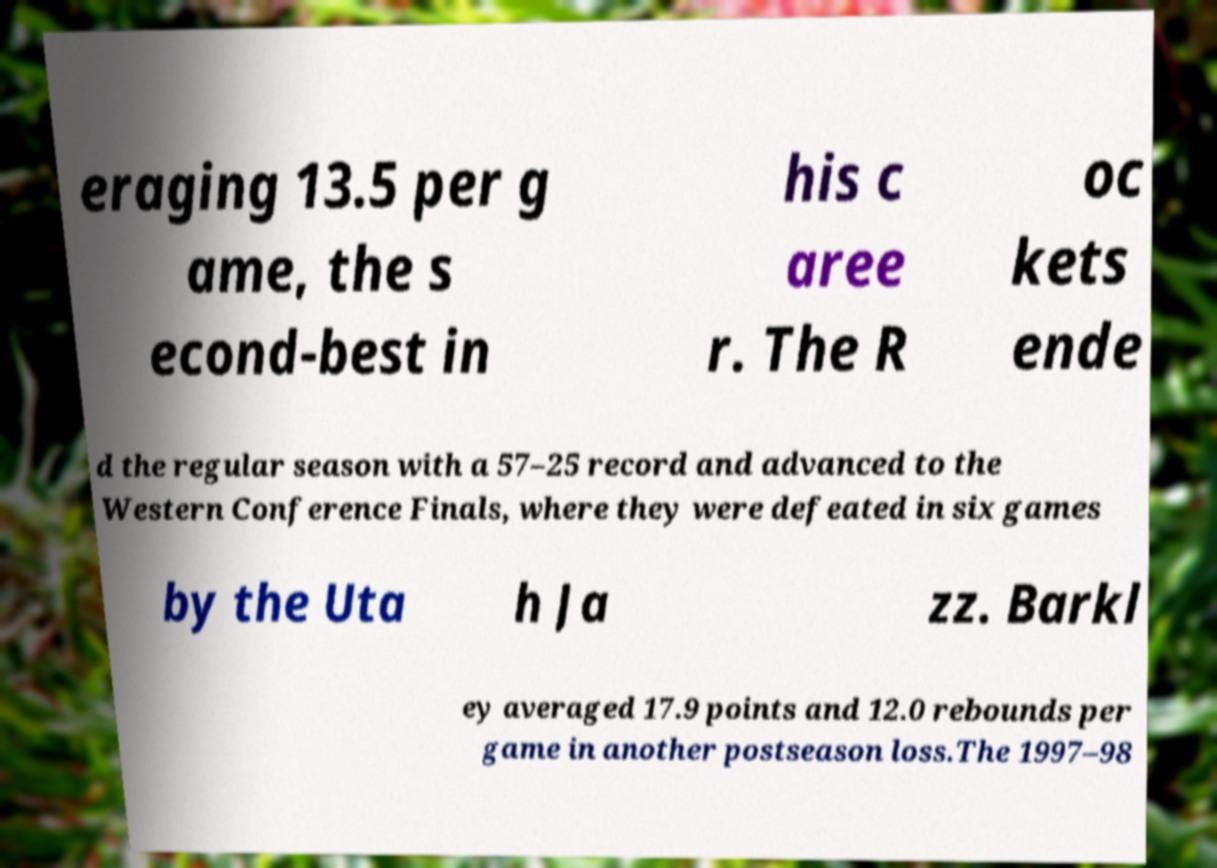Can you read and provide the text displayed in the image?This photo seems to have some interesting text. Can you extract and type it out for me? eraging 13.5 per g ame, the s econd-best in his c aree r. The R oc kets ende d the regular season with a 57–25 record and advanced to the Western Conference Finals, where they were defeated in six games by the Uta h Ja zz. Barkl ey averaged 17.9 points and 12.0 rebounds per game in another postseason loss.The 1997–98 